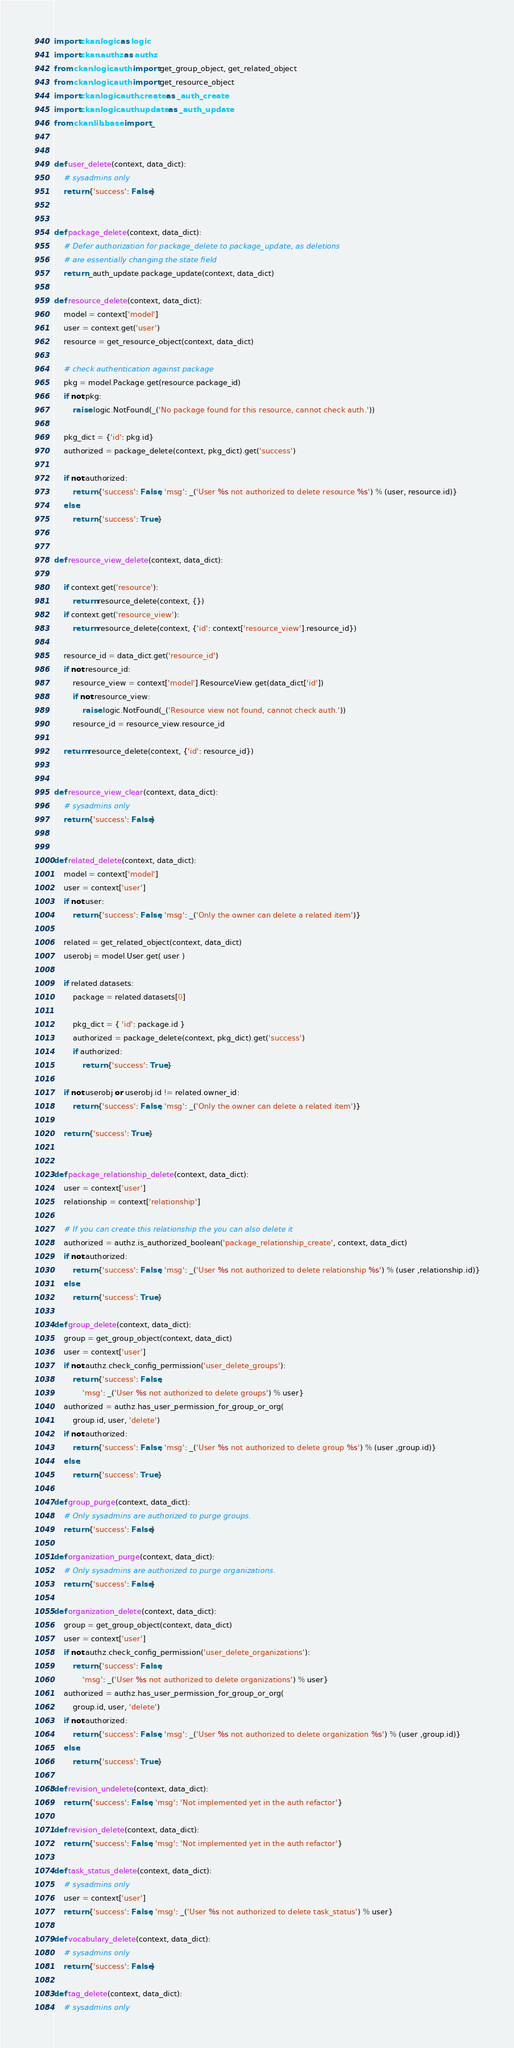<code> <loc_0><loc_0><loc_500><loc_500><_Python_>import ckan.logic as logic
import ckan.authz as authz
from ckan.logic.auth import get_group_object, get_related_object
from ckan.logic.auth import get_resource_object
import ckan.logic.auth.create as _auth_create
import ckan.logic.auth.update as _auth_update
from ckan.lib.base import _


def user_delete(context, data_dict):
    # sysadmins only
    return {'success': False}


def package_delete(context, data_dict):
    # Defer authorization for package_delete to package_update, as deletions
    # are essentially changing the state field
    return _auth_update.package_update(context, data_dict)

def resource_delete(context, data_dict):
    model = context['model']
    user = context.get('user')
    resource = get_resource_object(context, data_dict)

    # check authentication against package
    pkg = model.Package.get(resource.package_id)
    if not pkg:
        raise logic.NotFound(_('No package found for this resource, cannot check auth.'))

    pkg_dict = {'id': pkg.id}
    authorized = package_delete(context, pkg_dict).get('success')

    if not authorized:
        return {'success': False, 'msg': _('User %s not authorized to delete resource %s') % (user, resource.id)}
    else:
        return {'success': True}


def resource_view_delete(context, data_dict):

    if context.get('resource'):
        return resource_delete(context, {})
    if context.get('resource_view'):
        return resource_delete(context, {'id': context['resource_view'].resource_id})

    resource_id = data_dict.get('resource_id')
    if not resource_id:
        resource_view = context['model'].ResourceView.get(data_dict['id'])
        if not resource_view:
            raise logic.NotFound(_('Resource view not found, cannot check auth.'))
        resource_id = resource_view.resource_id

    return resource_delete(context, {'id': resource_id})


def resource_view_clear(context, data_dict):
    # sysadmins only
    return {'success': False}


def related_delete(context, data_dict):
    model = context['model']
    user = context['user']
    if not user:
        return {'success': False, 'msg': _('Only the owner can delete a related item')}

    related = get_related_object(context, data_dict)
    userobj = model.User.get( user )

    if related.datasets:
        package = related.datasets[0]

        pkg_dict = { 'id': package.id }
        authorized = package_delete(context, pkg_dict).get('success')
        if authorized:
            return {'success': True}

    if not userobj or userobj.id != related.owner_id:
        return {'success': False, 'msg': _('Only the owner can delete a related item')}

    return {'success': True}


def package_relationship_delete(context, data_dict):
    user = context['user']
    relationship = context['relationship']

    # If you can create this relationship the you can also delete it
    authorized = authz.is_authorized_boolean('package_relationship_create', context, data_dict)
    if not authorized:
        return {'success': False, 'msg': _('User %s not authorized to delete relationship %s') % (user ,relationship.id)}
    else:
        return {'success': True}

def group_delete(context, data_dict):
    group = get_group_object(context, data_dict)
    user = context['user']
    if not authz.check_config_permission('user_delete_groups'):
        return {'success': False,
            'msg': _('User %s not authorized to delete groups') % user}
    authorized = authz.has_user_permission_for_group_or_org(
        group.id, user, 'delete')
    if not authorized:
        return {'success': False, 'msg': _('User %s not authorized to delete group %s') % (user ,group.id)}
    else:
        return {'success': True}

def group_purge(context, data_dict):
    # Only sysadmins are authorized to purge groups.
    return {'success': False}

def organization_purge(context, data_dict):
    # Only sysadmins are authorized to purge organizations.
    return {'success': False}

def organization_delete(context, data_dict):
    group = get_group_object(context, data_dict)
    user = context['user']
    if not authz.check_config_permission('user_delete_organizations'):
        return {'success': False,
            'msg': _('User %s not authorized to delete organizations') % user}
    authorized = authz.has_user_permission_for_group_or_org(
        group.id, user, 'delete')
    if not authorized:
        return {'success': False, 'msg': _('User %s not authorized to delete organization %s') % (user ,group.id)}
    else:
        return {'success': True}

def revision_undelete(context, data_dict):
    return {'success': False, 'msg': 'Not implemented yet in the auth refactor'}

def revision_delete(context, data_dict):
    return {'success': False, 'msg': 'Not implemented yet in the auth refactor'}

def task_status_delete(context, data_dict):
    # sysadmins only
    user = context['user']
    return {'success': False, 'msg': _('User %s not authorized to delete task_status') % user}

def vocabulary_delete(context, data_dict):
    # sysadmins only
    return {'success': False}

def tag_delete(context, data_dict):
    # sysadmins only</code> 